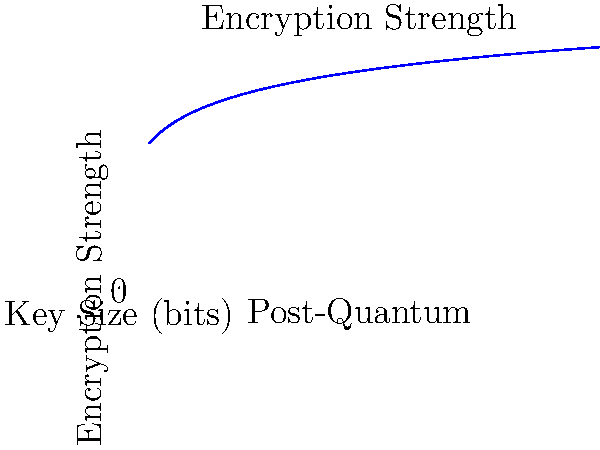Based on the line chart depicting the relationship between key size and encryption strength in post-quantum cryptography, what can be inferred about the rate of increase in encryption strength as the key size grows? To answer this question, let's analyze the graph step-by-step:

1. The x-axis represents the key size in bits, while the y-axis represents the encryption strength.

2. The curve is not linear but appears to be logarithmic in nature.

3. As we move from left to right (increasing key size):
   a. The curve rises steeply at first.
   b. The rate of increase gradually slows down.

4. This behavior is characteristic of a logarithmic function, specifically of the form $y = a \log_2(x)$, where:
   - $y$ is the encryption strength
   - $x$ is the key size
   - $a$ is a constant factor

5. In post-quantum cryptography, this relationship is often described by the equation:
   $\text{Encryption Strength} = 50 \log_2(\text{Key Size})$

6. The logarithmic nature implies that doubling the key size results in a constant increase in encryption strength, rather than doubling the strength.

7. For example:
   - Doubling from 64 to 128 bits increases strength by 50.
   - Doubling from 512 to 1024 bits also increases strength by 50.

Therefore, we can conclude that the encryption strength increases logarithmically with key size, meaning that the rate of increase in encryption strength diminishes as the key size grows larger.
Answer: Logarithmic increase; diminishing returns with larger key sizes 